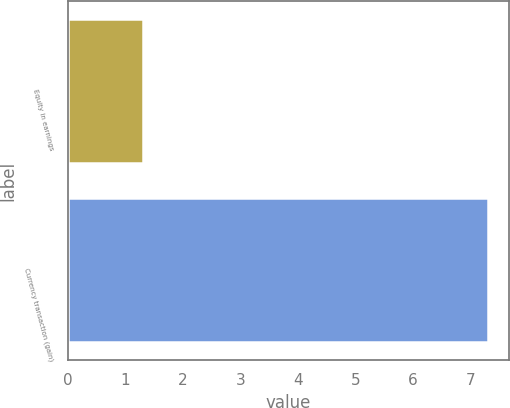Convert chart. <chart><loc_0><loc_0><loc_500><loc_500><bar_chart><fcel>Equity in earnings<fcel>Currency transaction (gain)<nl><fcel>1.3<fcel>7.3<nl></chart> 